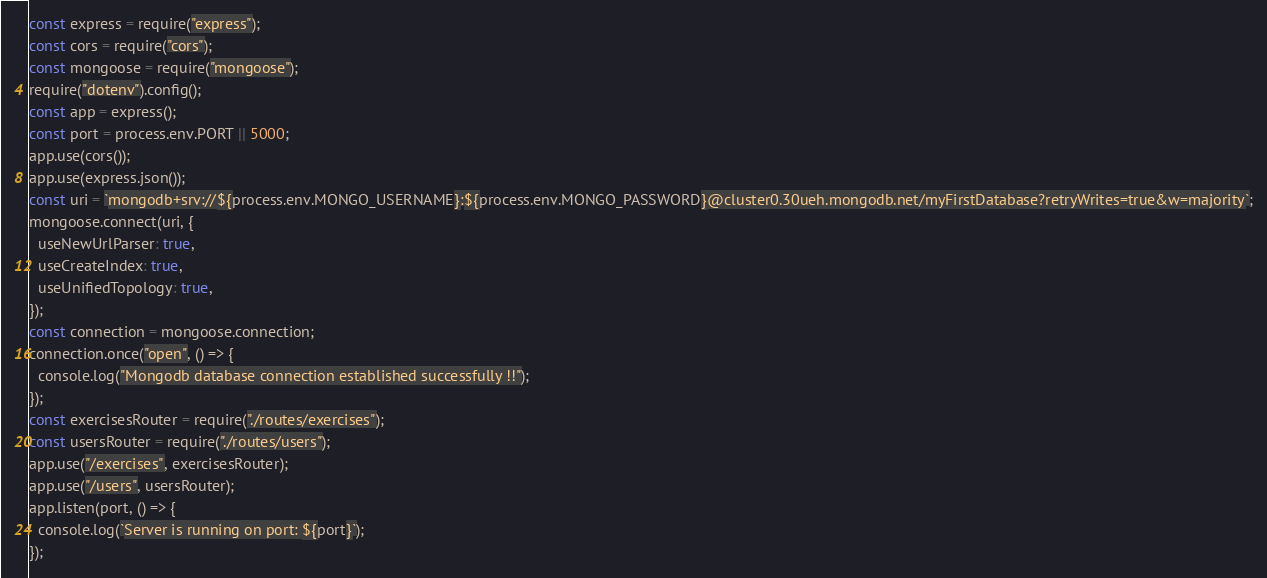<code> <loc_0><loc_0><loc_500><loc_500><_JavaScript_>const express = require("express");
const cors = require("cors");
const mongoose = require("mongoose");
require("dotenv").config();
const app = express();
const port = process.env.PORT || 5000;
app.use(cors());
app.use(express.json());
const uri = `mongodb+srv://${process.env.MONGO_USERNAME}:${process.env.MONGO_PASSWORD}@cluster0.30ueh.mongodb.net/myFirstDatabase?retryWrites=true&w=majority`;
mongoose.connect(uri, {
  useNewUrlParser: true,
  useCreateIndex: true,
  useUnifiedTopology: true,
});
const connection = mongoose.connection;
connection.once("open", () => {
  console.log("Mongodb database connection established successfully !!");
});
const exercisesRouter = require("./routes/exercises");
const usersRouter = require("./routes/users");
app.use("/exercises", exercisesRouter);
app.use("/users", usersRouter);
app.listen(port, () => {
  console.log(`Server is running on port: ${port}`);
});
</code> 